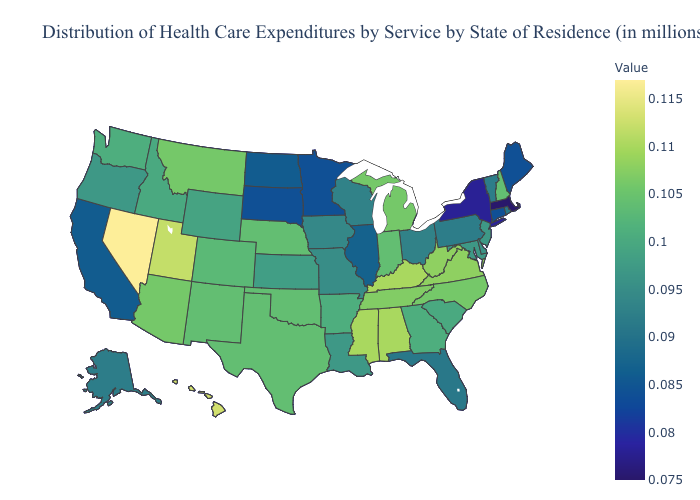Does Missouri have a lower value than New York?
Give a very brief answer. No. Which states have the highest value in the USA?
Keep it brief. Nevada. Which states have the highest value in the USA?
Concise answer only. Nevada. Is the legend a continuous bar?
Quick response, please. Yes. 